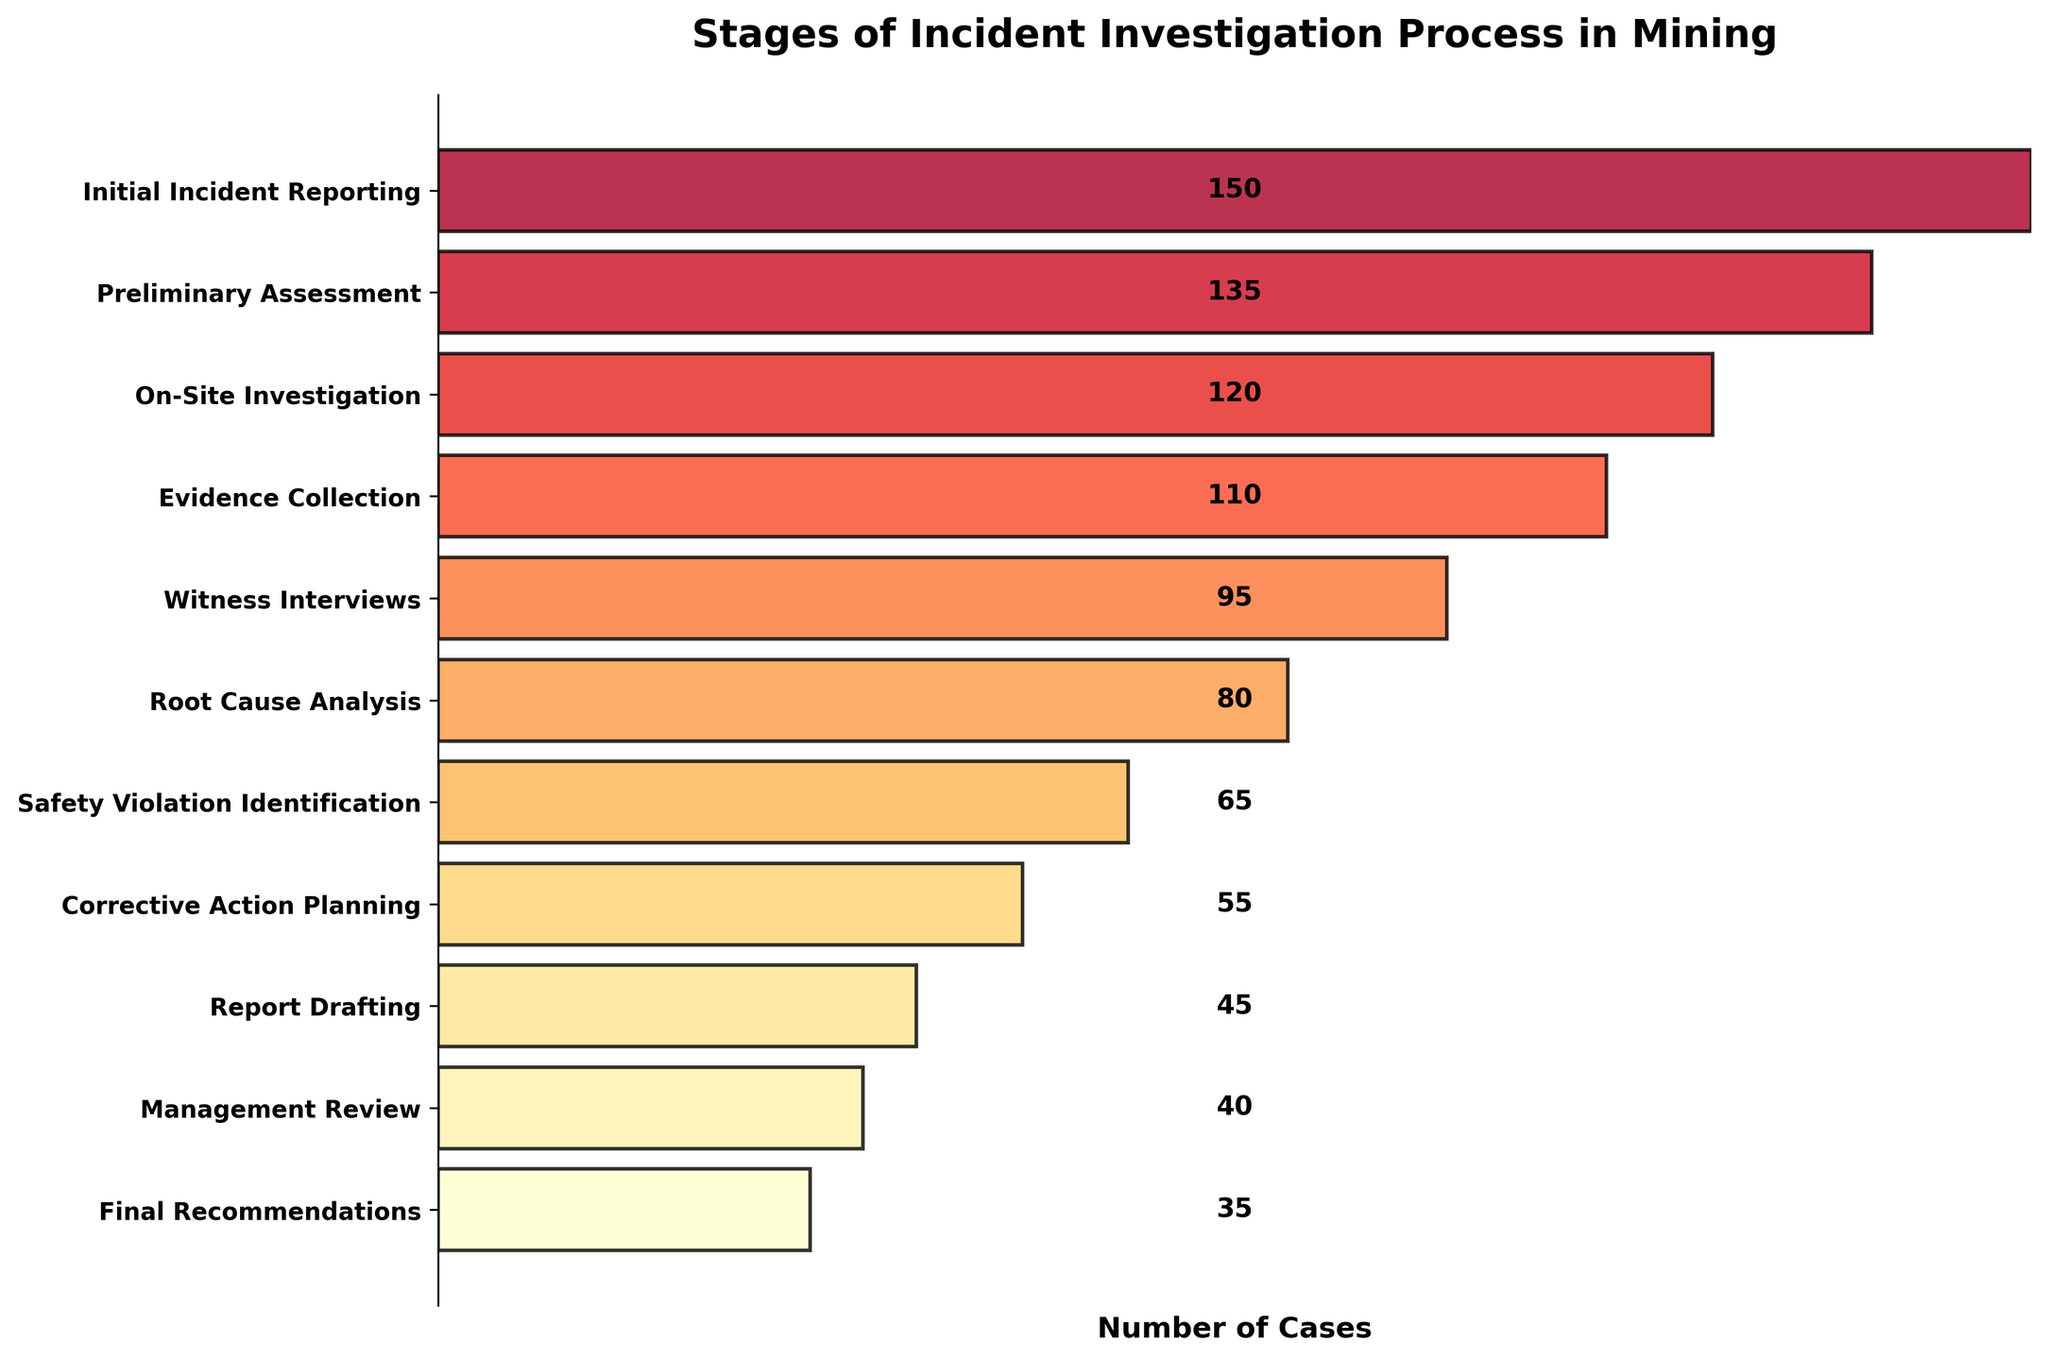What is the title of the figure? The title is usually placed at the top of the chart to describe what the chart is about. Here, the title at the top reads "Stages of Incident Investigation Process in Mining."
Answer: Stages of Incident Investigation Process in Mining Which stage has the highest number of cases? To find the stage with the highest number of cases, look for the stage at the top of the funnel, as it visually represents the initial and largest number of cases. The top stage is "Initial Incident Reporting" with 150 cases.
Answer: Initial Incident Reporting How many stages are involved in the incident investigation process? The funnel chart typically represents stages in a process. Count the distinct bars/labels on the y-axis to determine the number of stages. There are 11 stages.
Answer: 11 What is the difference in the number of cases between the "Initial Incident Reporting" stage and the "Final Recommendations" stage? Subtract the number of cases in the "Final Recommendations" stage (35) from the number of cases in the "Initial Incident Reporting" stage (150): 150 - 35.
Answer: 115 Which stage has fewer cases, "Root Cause Analysis" or "Safety Violation Identification"? Compare the number of cases between the "Root Cause Analysis" (80 cases) and "Safety Violation Identification" (65 cases) stages directly.
Answer: Safety Violation Identification What is the percentage drop in cases from the "On-Site Investigation" stage to the "Evidence Collection" stage? Calculate the difference in the number of cases between the "On-Site Investigation" (120) and "Evidence Collection" (110) stages and then divide by the "On-Site Investigation" number of cases, and multiply by 100 to get the percentage: ((120 - 110) / 120) * 100.
Answer: 8.33% What is the average number of cases across all stages? Add up the number of cases for all 11 stages and then divide by the number of stages: (150 + 135 + 120 + 110 + 95 + 80 + 65 + 55 + 45 + 40 + 35) / 11.
Answer: 84.09 Which stage marks the halfway point of the investigation in terms of the number of stages? Since there are 11 stages, the halfway point would be the 6th stage (rounding down since stages are discrete). The 6th stage is "Root Cause Analysis."
Answer: Root Cause Analysis At which stage do the number of cases drop below 100 for the first time? Examine the stages sequentially to identify the first stage with less than 100 cases; "Witness Interviews" has 95 cases, making it the first.
Answer: Witness Interviews 